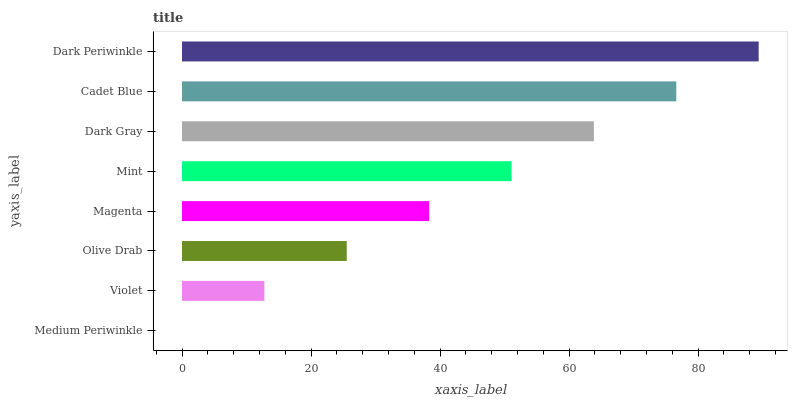Is Medium Periwinkle the minimum?
Answer yes or no. Yes. Is Dark Periwinkle the maximum?
Answer yes or no. Yes. Is Violet the minimum?
Answer yes or no. No. Is Violet the maximum?
Answer yes or no. No. Is Violet greater than Medium Periwinkle?
Answer yes or no. Yes. Is Medium Periwinkle less than Violet?
Answer yes or no. Yes. Is Medium Periwinkle greater than Violet?
Answer yes or no. No. Is Violet less than Medium Periwinkle?
Answer yes or no. No. Is Mint the high median?
Answer yes or no. Yes. Is Magenta the low median?
Answer yes or no. Yes. Is Magenta the high median?
Answer yes or no. No. Is Violet the low median?
Answer yes or no. No. 